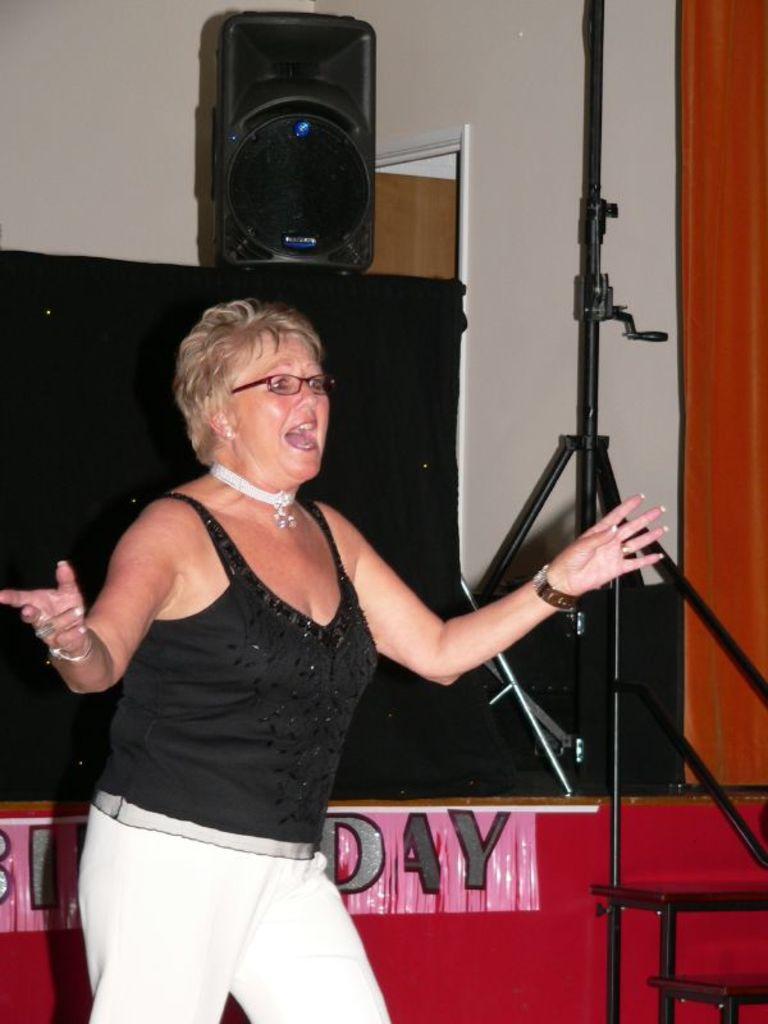What is on the pink banner?
Your answer should be very brief. Day. 